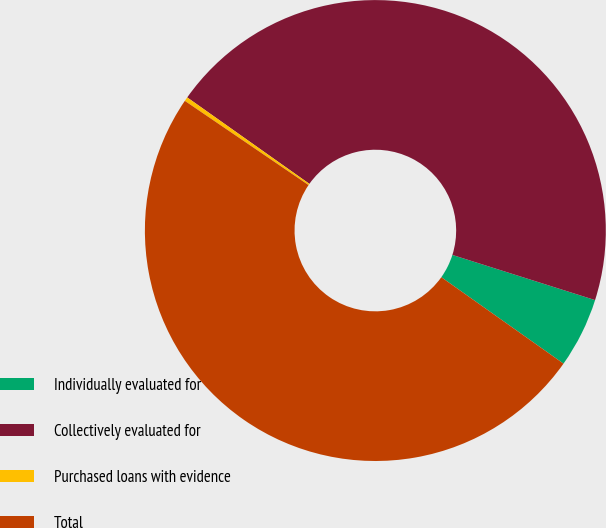Convert chart to OTSL. <chart><loc_0><loc_0><loc_500><loc_500><pie_chart><fcel>Individually evaluated for<fcel>Collectively evaluated for<fcel>Purchased loans with evidence<fcel>Total<nl><fcel>4.92%<fcel>45.08%<fcel>0.29%<fcel>49.71%<nl></chart> 